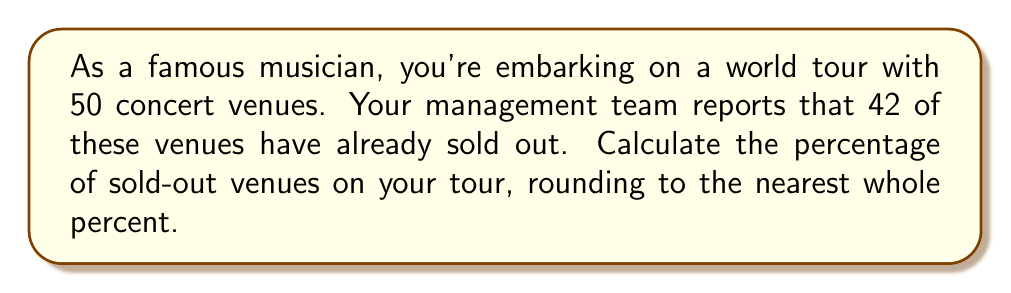Can you solve this math problem? To solve this problem, we'll follow these steps:

1. Identify the total number of venues and the number of sold-out venues:
   Total venues: $n = 50$
   Sold-out venues: $s = 42$

2. Calculate the percentage using the formula:
   $$ \text{Percentage} = \frac{\text{Part}}{\text{Whole}} \times 100\% $$

3. Plug in our values:
   $$ \text{Percentage} = \frac{s}{n} \times 100\% = \frac{42}{50} \times 100\% $$

4. Perform the division:
   $$ \frac{42}{50} = 0.84 $$

5. Multiply by 100%:
   $$ 0.84 \times 100\% = 84\% $$

6. Round to the nearest whole percent:
   $84\%$ is already a whole number, so no rounding is necessary.

Therefore, the percentage of sold-out venues on your tour is 84%.
Answer: 84% 